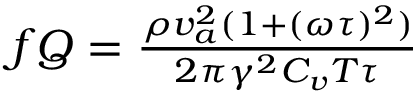<formula> <loc_0><loc_0><loc_500><loc_500>\begin{array} { r } { f Q = \frac { \rho v _ { a } ^ { 2 } ( 1 + ( \omega \tau ) ^ { 2 } ) } { 2 \pi \gamma ^ { 2 } C _ { v } T \tau } } \end{array}</formula> 